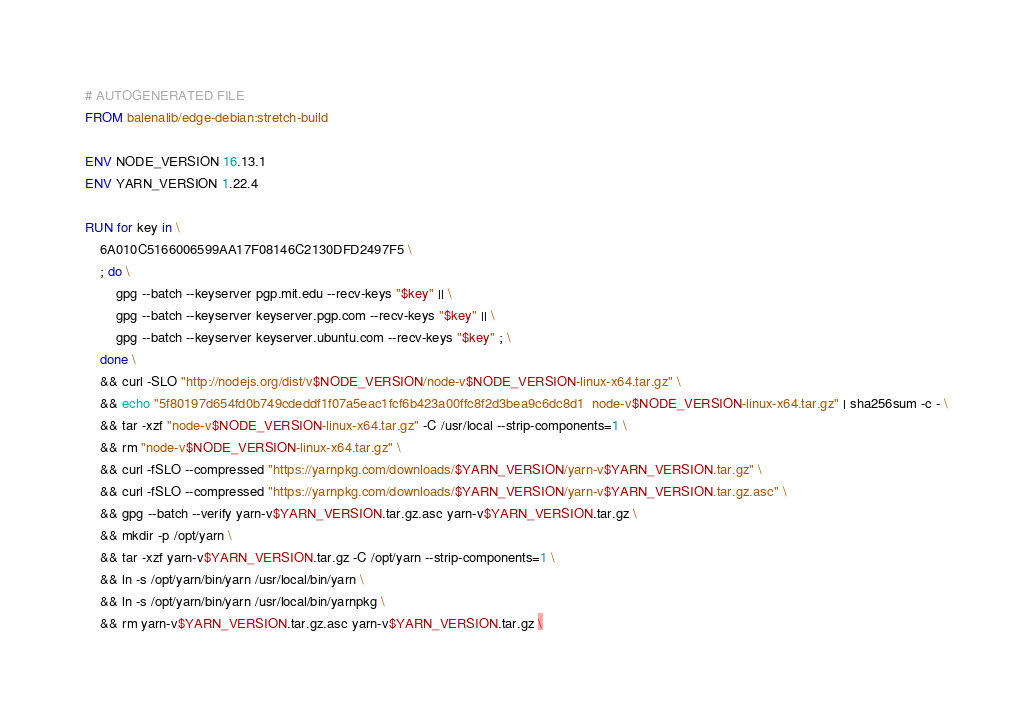Convert code to text. <code><loc_0><loc_0><loc_500><loc_500><_Dockerfile_># AUTOGENERATED FILE
FROM balenalib/edge-debian:stretch-build

ENV NODE_VERSION 16.13.1
ENV YARN_VERSION 1.22.4

RUN for key in \
	6A010C5166006599AA17F08146C2130DFD2497F5 \
	; do \
		gpg --batch --keyserver pgp.mit.edu --recv-keys "$key" || \
		gpg --batch --keyserver keyserver.pgp.com --recv-keys "$key" || \
		gpg --batch --keyserver keyserver.ubuntu.com --recv-keys "$key" ; \
	done \
	&& curl -SLO "http://nodejs.org/dist/v$NODE_VERSION/node-v$NODE_VERSION-linux-x64.tar.gz" \
	&& echo "5f80197d654fd0b749cdeddf1f07a5eac1fcf6b423a00ffc8f2d3bea9c6dc8d1  node-v$NODE_VERSION-linux-x64.tar.gz" | sha256sum -c - \
	&& tar -xzf "node-v$NODE_VERSION-linux-x64.tar.gz" -C /usr/local --strip-components=1 \
	&& rm "node-v$NODE_VERSION-linux-x64.tar.gz" \
	&& curl -fSLO --compressed "https://yarnpkg.com/downloads/$YARN_VERSION/yarn-v$YARN_VERSION.tar.gz" \
	&& curl -fSLO --compressed "https://yarnpkg.com/downloads/$YARN_VERSION/yarn-v$YARN_VERSION.tar.gz.asc" \
	&& gpg --batch --verify yarn-v$YARN_VERSION.tar.gz.asc yarn-v$YARN_VERSION.tar.gz \
	&& mkdir -p /opt/yarn \
	&& tar -xzf yarn-v$YARN_VERSION.tar.gz -C /opt/yarn --strip-components=1 \
	&& ln -s /opt/yarn/bin/yarn /usr/local/bin/yarn \
	&& ln -s /opt/yarn/bin/yarn /usr/local/bin/yarnpkg \
	&& rm yarn-v$YARN_VERSION.tar.gz.asc yarn-v$YARN_VERSION.tar.gz \</code> 